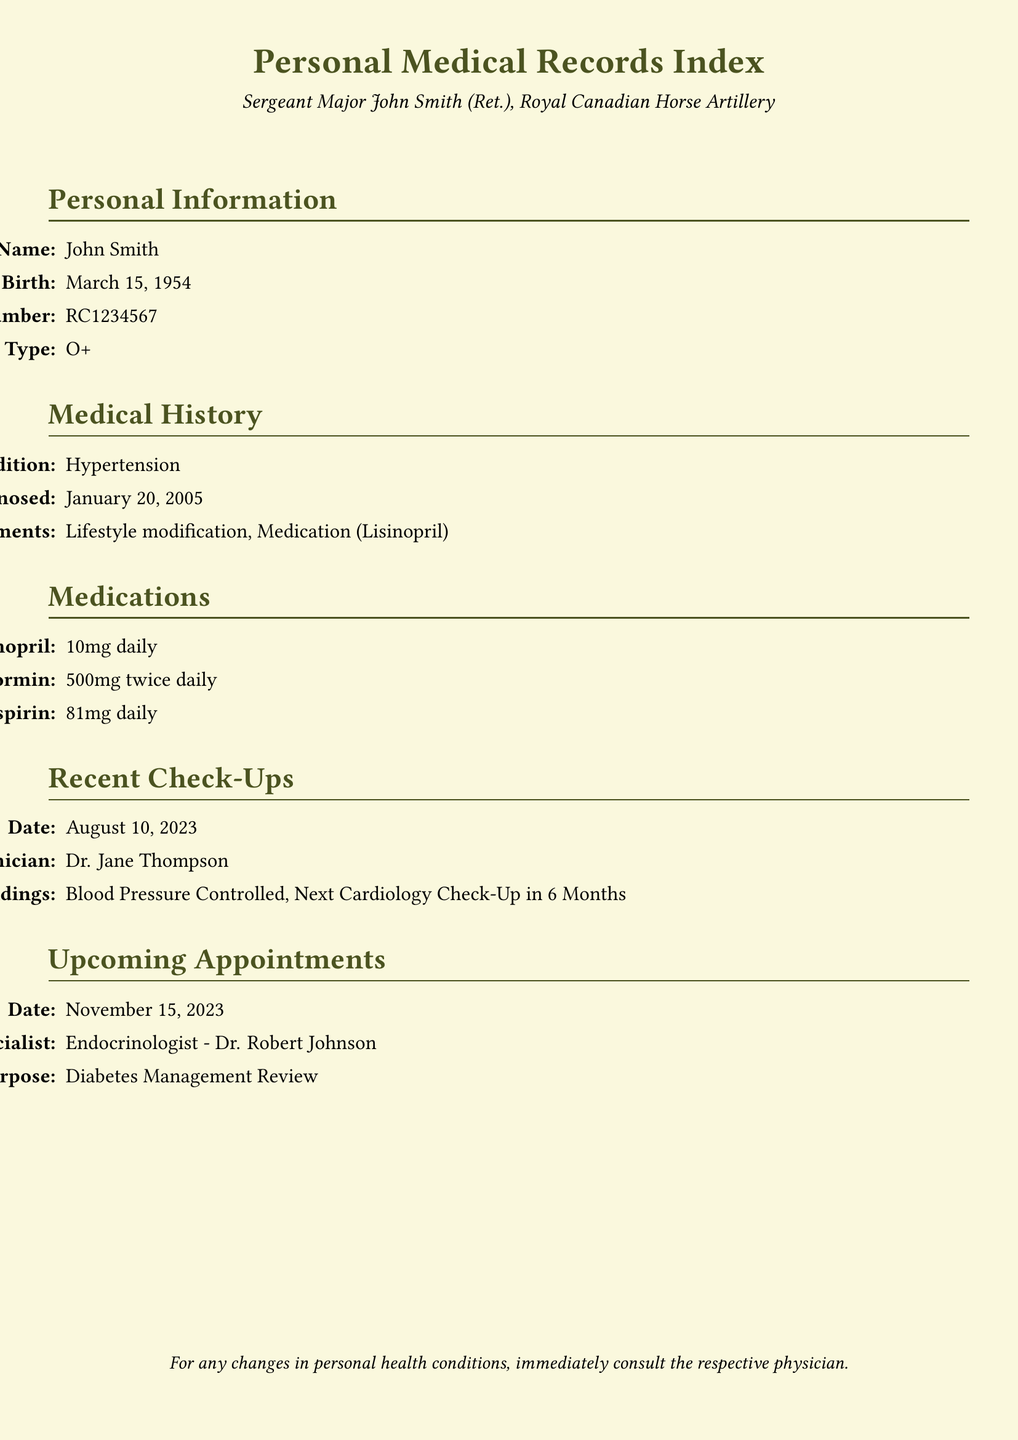What is the full name of the individual? The individual's full name is listed as John Smith in the document.
Answer: John Smith When was the individual first diagnosed with hypertension? The date of first diagnosis for hypertension is provided in the medical history section.
Answer: January 20, 2005 What medication is prescribed for diabetes management? Since Metformin is a diabetes medication listed, it indicates relevance to diabetes management.
Answer: Metformin Who is the clinician for the most recent check-up? The clinician's name is provided as Dr. Jane Thompson in the recent check-ups section.
Answer: Dr. Jane Thompson What is the purpose of the upcoming appointment? The purpose of the upcoming appointment is stated clearly in the upcoming appointments section.
Answer: Diabetes Management Review How often is Lisinopril taken? The frequency of Lisinopril use is mentioned in the medications section of the document.
Answer: Daily What were the findings from the August 10, 2023 check-up? The findings from the check-up are noted in the recent check-ups section.
Answer: Blood Pressure Controlled What is the blood type of the individual? The individual's blood type is explicitly listed in the personal information section.
Answer: O+ When is the next cardiology check-up scheduled? The next cardiology check-up is inferred from the recent check-ups section's findings.
Answer: In 6 Months 